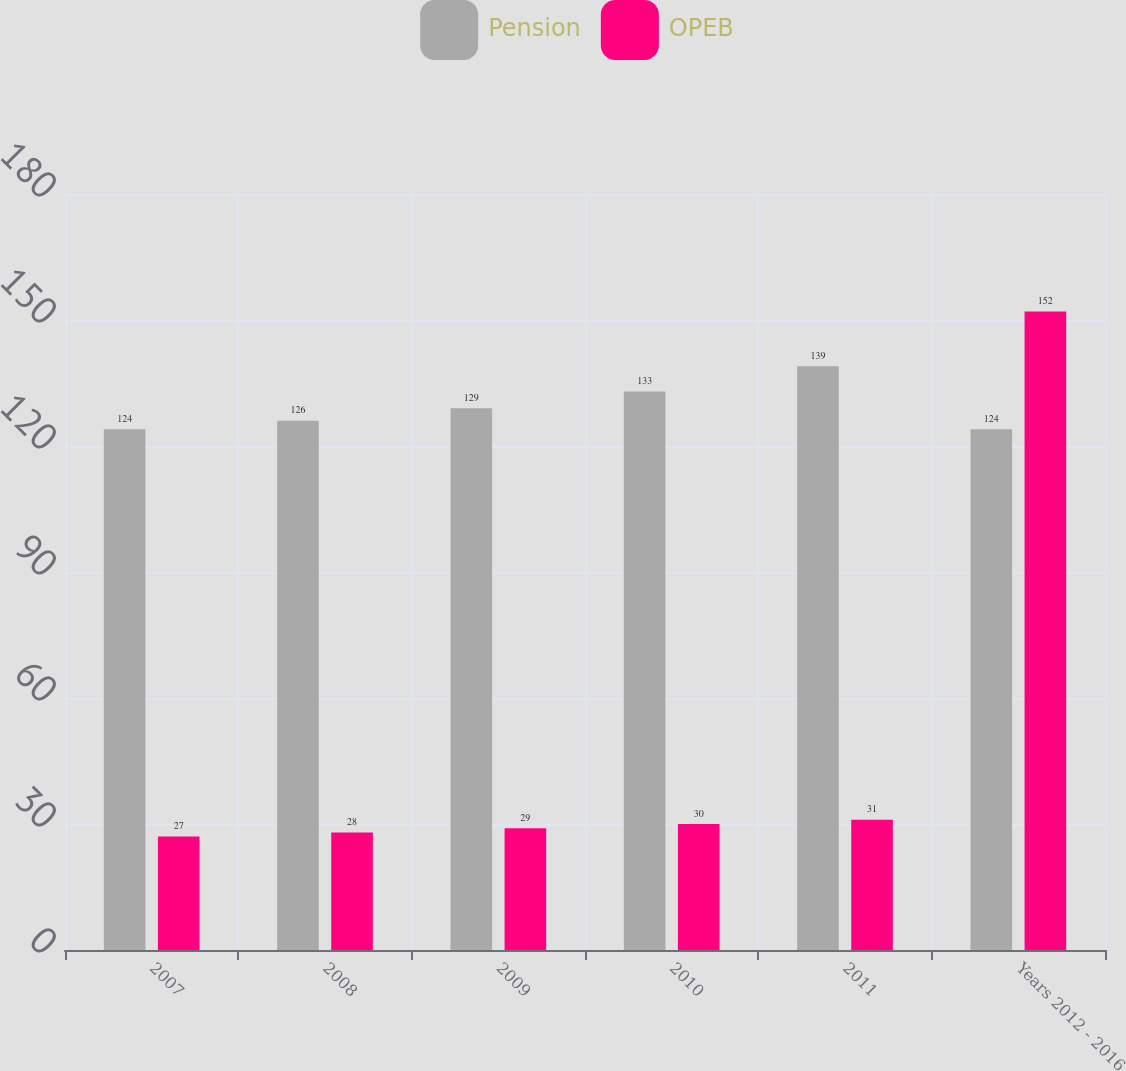Convert chart. <chart><loc_0><loc_0><loc_500><loc_500><stacked_bar_chart><ecel><fcel>2007<fcel>2008<fcel>2009<fcel>2010<fcel>2011<fcel>Years 2012 - 2016<nl><fcel>Pension<fcel>124<fcel>126<fcel>129<fcel>133<fcel>139<fcel>124<nl><fcel>OPEB<fcel>27<fcel>28<fcel>29<fcel>30<fcel>31<fcel>152<nl></chart> 